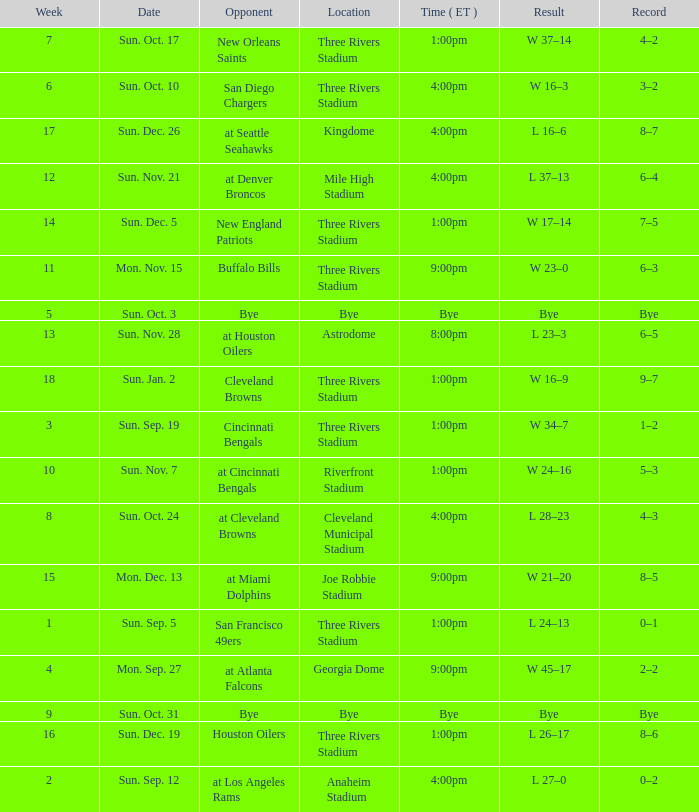What is the record of the game that has a result of w 45–17? 2–2. 